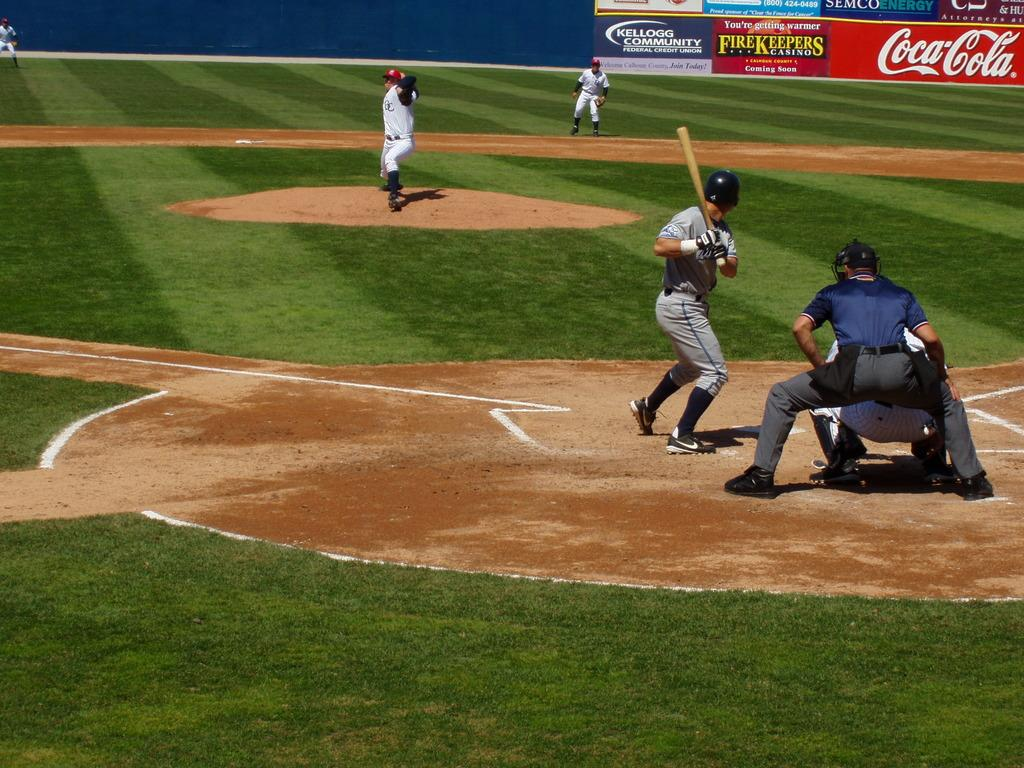<image>
Render a clear and concise summary of the photo. A Coca Cola sign is on the wall of a baseball field that is being played on. 